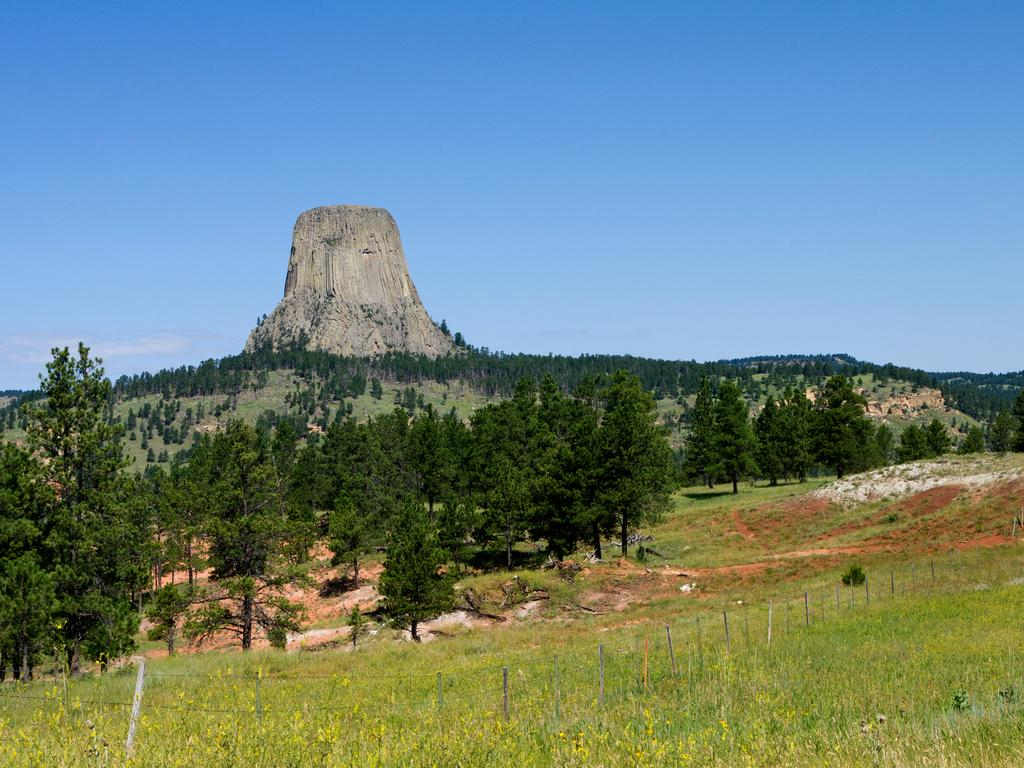What type of vegetation can be seen in the image? There are trees in the image. What type of barrier is present in the image? There is a fence in the image. What type of ground cover is visible in the image? There is grass in the image. What geographical feature is present in the image? There is a mountain in the image. What can be seen in the background of the image? The sky is visible in the background of the image. What type of rose is blooming in the downtown area in the image? There is no rose or downtown area present in the image; it features trees, a fence, grass, a mountain, and the sky. 